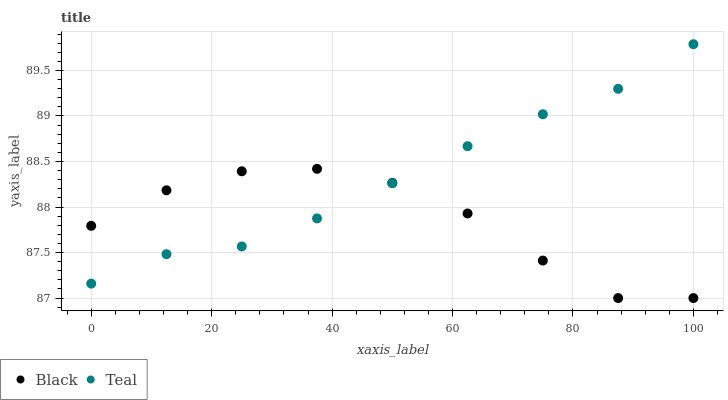Does Black have the minimum area under the curve?
Answer yes or no. Yes. Does Teal have the maximum area under the curve?
Answer yes or no. Yes. Does Teal have the minimum area under the curve?
Answer yes or no. No. Is Teal the smoothest?
Answer yes or no. Yes. Is Black the roughest?
Answer yes or no. Yes. Is Teal the roughest?
Answer yes or no. No. Does Black have the lowest value?
Answer yes or no. Yes. Does Teal have the lowest value?
Answer yes or no. No. Does Teal have the highest value?
Answer yes or no. Yes. Does Teal intersect Black?
Answer yes or no. Yes. Is Teal less than Black?
Answer yes or no. No. Is Teal greater than Black?
Answer yes or no. No. 